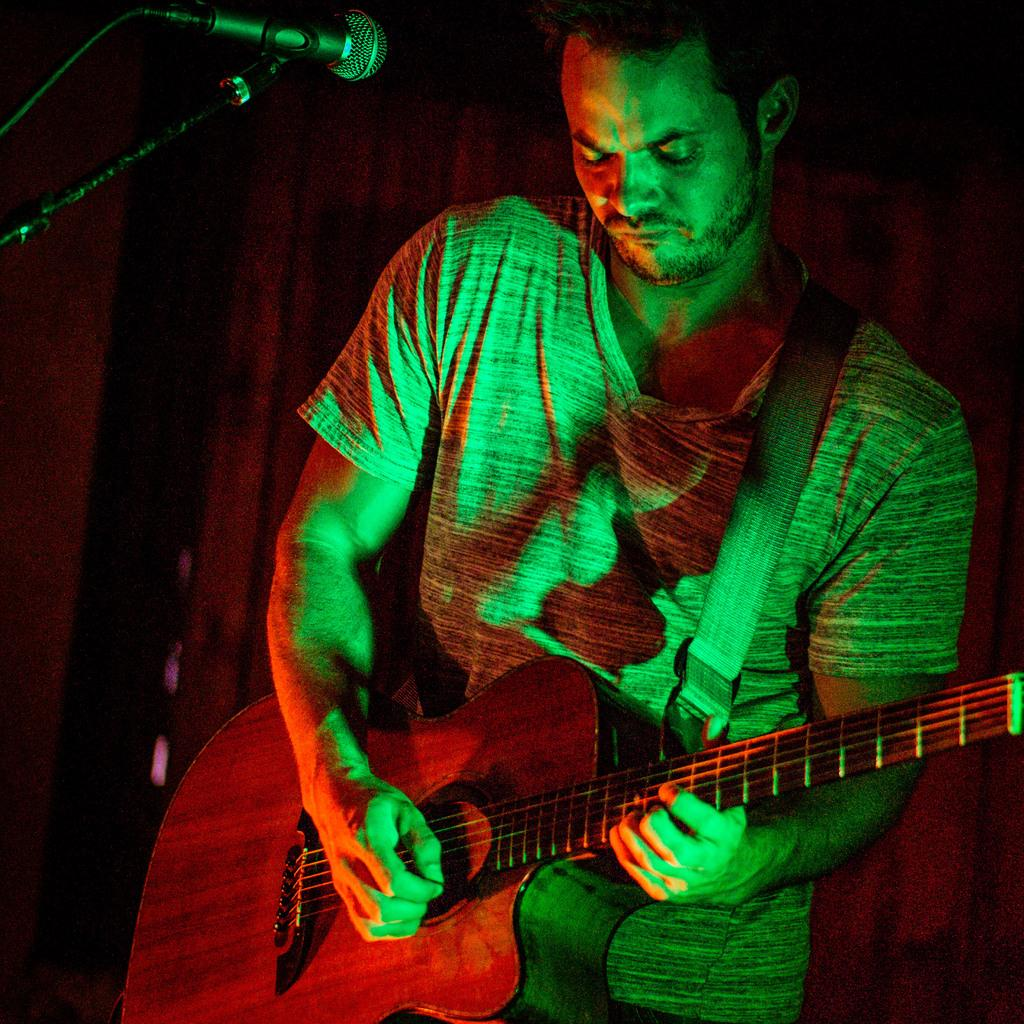What is the man in the image doing? The man is playing a guitar in the image. How is the man positioned in the image? The man is standing in the image. What object is present in the image that is typically used for amplifying sound? There is a microphone in the image, which is fixed on a microphone stand. Can you tell me how many matches the man is holding in the image? There are no matches present in the image; the man is playing a guitar and there is a microphone with a stand. 